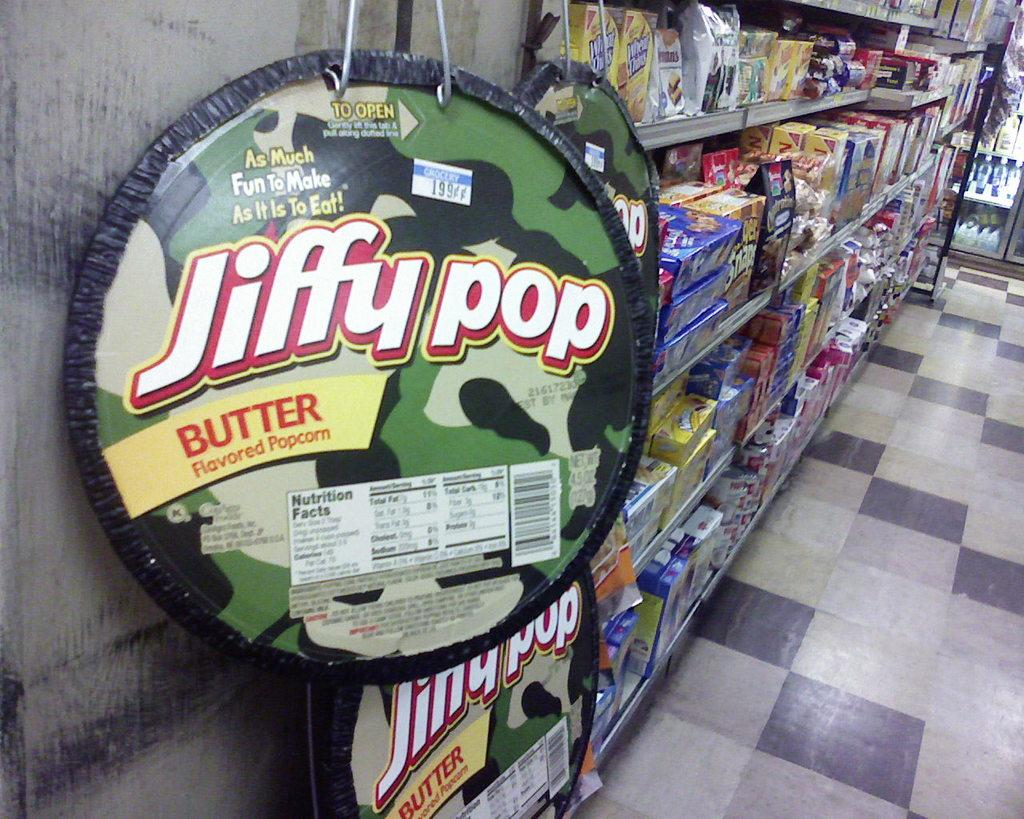Provide a one-sentence caption for the provided image. jiffy pop popcorn on display at the grocery store. 